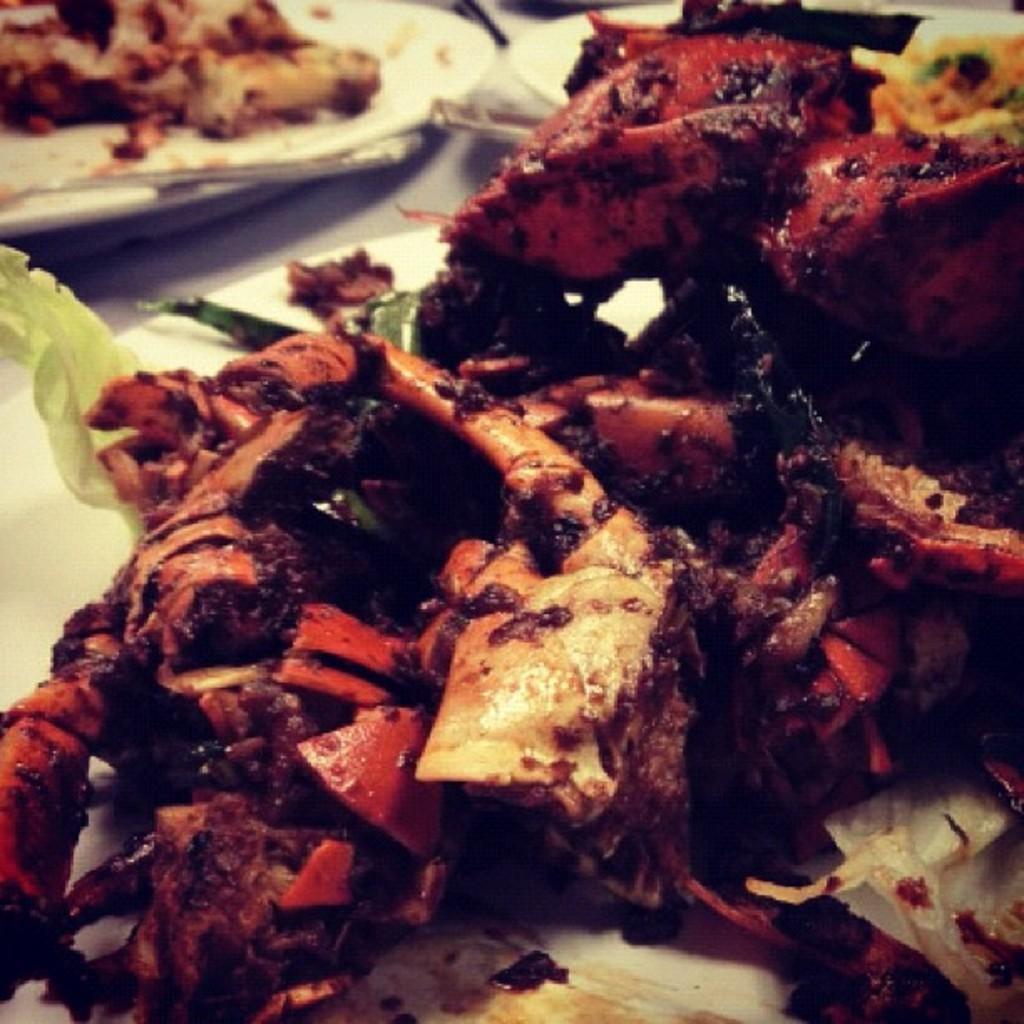Can you describe this image briefly? In this image we a food item kept on the plate. In the background, we can see a few more plates with food and spoons kept on it are placed on the white color surface. 